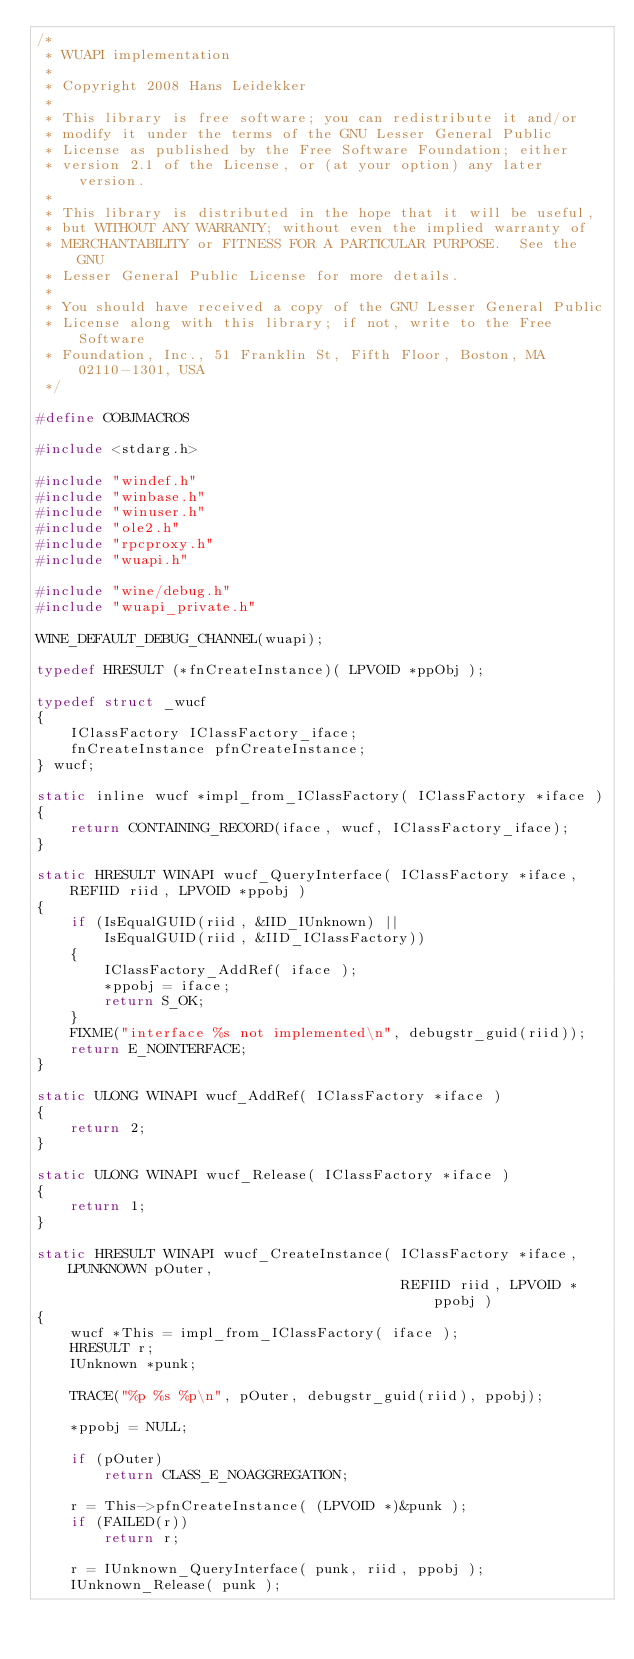Convert code to text. <code><loc_0><loc_0><loc_500><loc_500><_C_>/*
 * WUAPI implementation
 *
 * Copyright 2008 Hans Leidekker
 *
 * This library is free software; you can redistribute it and/or
 * modify it under the terms of the GNU Lesser General Public
 * License as published by the Free Software Foundation; either
 * version 2.1 of the License, or (at your option) any later version.
 *
 * This library is distributed in the hope that it will be useful,
 * but WITHOUT ANY WARRANTY; without even the implied warranty of
 * MERCHANTABILITY or FITNESS FOR A PARTICULAR PURPOSE.  See the GNU
 * Lesser General Public License for more details.
 *
 * You should have received a copy of the GNU Lesser General Public
 * License along with this library; if not, write to the Free Software
 * Foundation, Inc., 51 Franklin St, Fifth Floor, Boston, MA 02110-1301, USA
 */

#define COBJMACROS

#include <stdarg.h>

#include "windef.h"
#include "winbase.h"
#include "winuser.h"
#include "ole2.h"
#include "rpcproxy.h"
#include "wuapi.h"

#include "wine/debug.h"
#include "wuapi_private.h"

WINE_DEFAULT_DEBUG_CHANNEL(wuapi);

typedef HRESULT (*fnCreateInstance)( LPVOID *ppObj );

typedef struct _wucf
{
    IClassFactory IClassFactory_iface;
    fnCreateInstance pfnCreateInstance;
} wucf;

static inline wucf *impl_from_IClassFactory( IClassFactory *iface )
{
    return CONTAINING_RECORD(iface, wucf, IClassFactory_iface);
}

static HRESULT WINAPI wucf_QueryInterface( IClassFactory *iface, REFIID riid, LPVOID *ppobj )
{
    if (IsEqualGUID(riid, &IID_IUnknown) ||
        IsEqualGUID(riid, &IID_IClassFactory))
    {
        IClassFactory_AddRef( iface );
        *ppobj = iface;
        return S_OK;
    }
    FIXME("interface %s not implemented\n", debugstr_guid(riid));
    return E_NOINTERFACE;
}

static ULONG WINAPI wucf_AddRef( IClassFactory *iface )
{
    return 2;
}

static ULONG WINAPI wucf_Release( IClassFactory *iface )
{
    return 1;
}

static HRESULT WINAPI wucf_CreateInstance( IClassFactory *iface, LPUNKNOWN pOuter,
                                           REFIID riid, LPVOID *ppobj )
{
    wucf *This = impl_from_IClassFactory( iface );
    HRESULT r;
    IUnknown *punk;

    TRACE("%p %s %p\n", pOuter, debugstr_guid(riid), ppobj);

    *ppobj = NULL;

    if (pOuter)
        return CLASS_E_NOAGGREGATION;

    r = This->pfnCreateInstance( (LPVOID *)&punk );
    if (FAILED(r))
        return r;

    r = IUnknown_QueryInterface( punk, riid, ppobj );
    IUnknown_Release( punk );</code> 